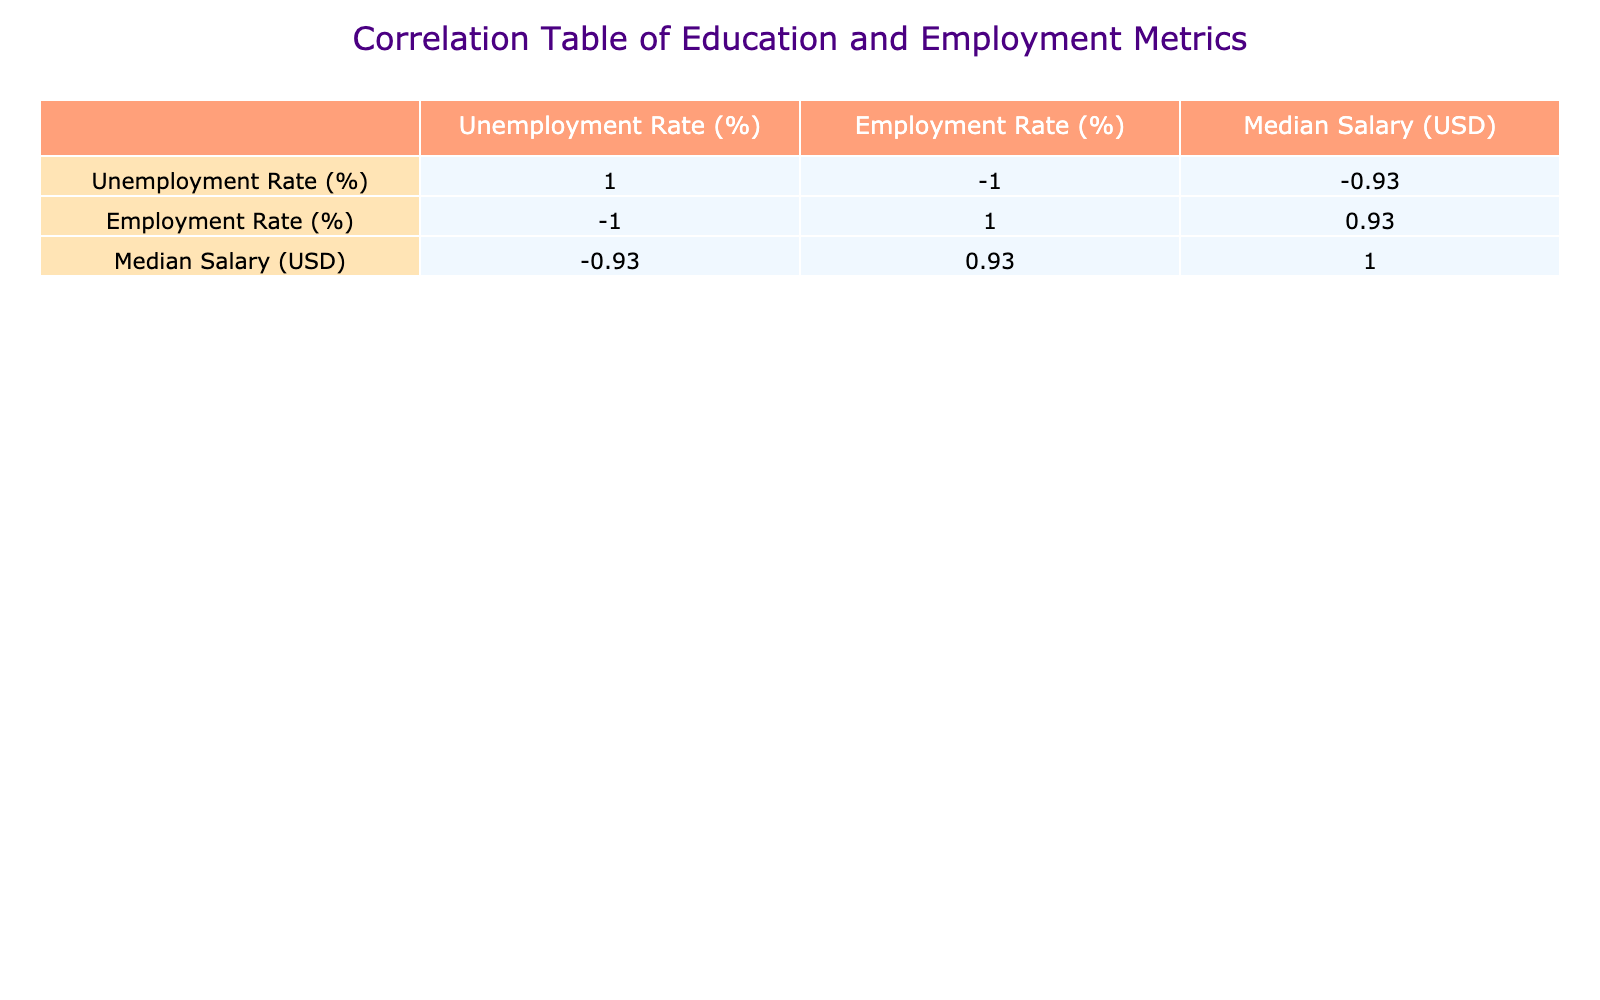What is the unemployment rate for higher education (Bachelor's) graduates? The table indicates that the unemployment rate for higher education (Bachelor's) graduates is 10.0% as listed in the row corresponding to "Higher Education (Bachelor's)."
Answer: 10.0% Which education level has the highest unemployment rate? By looking at the unemployment rates in the table, Primary Education has the highest rate at 30.5%, as this value is the largest compared to others in the column for Unemployment Rate (%).
Answer: Primary Education What is the difference in employment rates between vocational training graduates and those with primary education? The employment rate for vocational training is 85.0% and for primary education it is 69.5%. The difference is calculated as 85.0% - 69.5% = 15.5%.
Answer: 15.5% Is the relationship between education level and median salary positive or negative? The table shows that as the education level increases, the median salary also increases. For example, primary education has a median salary of 1500 USD while a PhD has 8000 USD, indicating a positive relationship.
Answer: Positive What is the average median salary for individuals with higher education (both Bachelor's and Master's)? The median salary for Bachelor's is 4500 USD and for Master's is 6000 USD. The sum of these salaries is 4500 + 6000 = 10500 USD, and dividing this by the 2 groups gives an average of 10500 / 2 = 5250 USD.
Answer: 5250 USD Does vocational training result in a lower unemployment rate than secondary education? The unemployment rate for vocational training is 15.0% and for secondary education is 20.2%. Since 15.0% is less than 20.2%, vocational training does lead to a lower unemployment rate.
Answer: Yes How many education levels listed have an unemployment rate of less than 10%? Looking at the data, only the PhD category shows an unemployment rate of 3.0%, which is the only instance of an unemployment rate below 10%. Thus, there is only 1 education level.
Answer: 1 Calculate the total employment rate across all listed education levels. Summing the employment rates (69.5% + 79.8% + 85.0% + 90.0% + 95.0% + 97.0%) gives a total of 596.3%. To find the average total employment rate across the 6 education levels, divide by 6: 596.3 / 6 = 99.38%.
Answer: 99.38% 